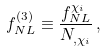<formula> <loc_0><loc_0><loc_500><loc_500>f _ { N L } ^ { ( 3 ) } \equiv \frac { f _ { N L } ^ { \chi _ { i } } } { N _ { , \chi _ { i } } } \, ,</formula> 